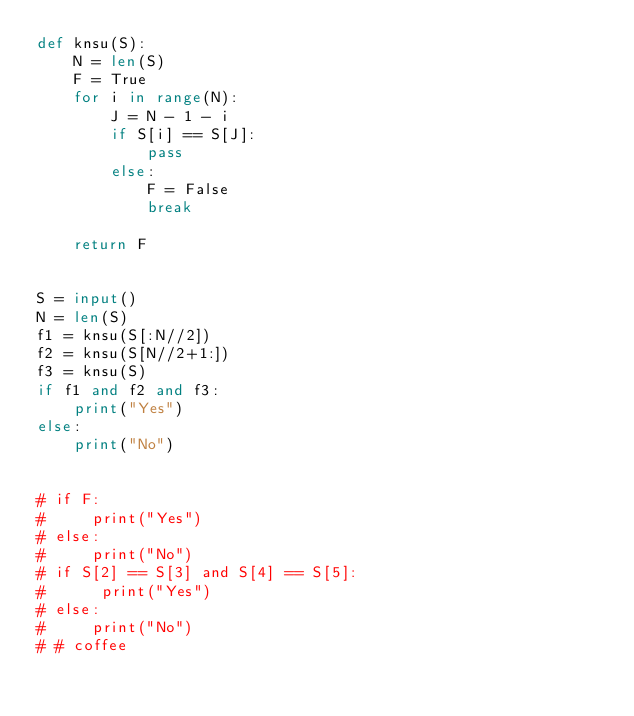Convert code to text. <code><loc_0><loc_0><loc_500><loc_500><_Python_>def knsu(S):
    N = len(S)
    F = True
    for i in range(N):
        J = N - 1 - i
        if S[i] == S[J]:
            pass
        else:
            F = False
            break

    return F


S = input()
N = len(S)
f1 = knsu(S[:N//2])
f2 = knsu(S[N//2+1:])
f3 = knsu(S)
if f1 and f2 and f3:
    print("Yes")
else:
    print("No")


# if F:
#     print("Yes")
# else:
#     print("No")
# if S[2] == S[3] and S[4] == S[5]:
#      print("Yes")
# else:
#     print("No")
# # coffee
</code> 